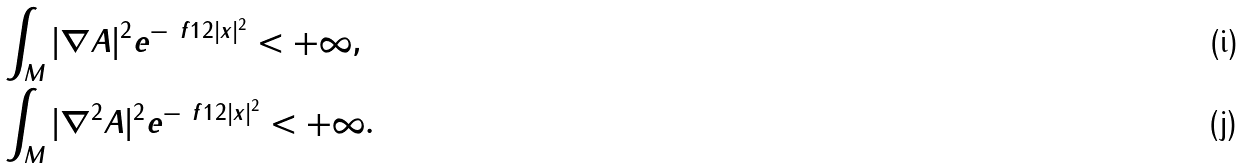<formula> <loc_0><loc_0><loc_500><loc_500>& \int _ { M } | \nabla A | ^ { 2 } e ^ { - \ f 1 2 | x | ^ { 2 } } < + \infty , \\ & \int _ { M } | \nabla ^ { 2 } A | ^ { 2 } e ^ { - \ f 1 2 | x | ^ { 2 } } < + \infty .</formula> 